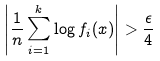Convert formula to latex. <formula><loc_0><loc_0><loc_500><loc_500>\left | \frac { 1 } { n } \sum _ { i = 1 } ^ { k } \log f _ { i } ( x ) \right | > \frac { \epsilon } { 4 }</formula> 